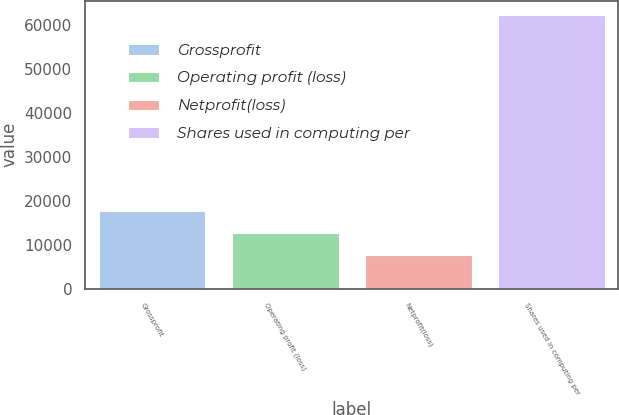Convert chart to OTSL. <chart><loc_0><loc_0><loc_500><loc_500><bar_chart><fcel>Grossprofit<fcel>Operating profit (loss)<fcel>Netprofit(loss)<fcel>Shares used in computing per<nl><fcel>17705<fcel>12732<fcel>7759<fcel>62462<nl></chart> 